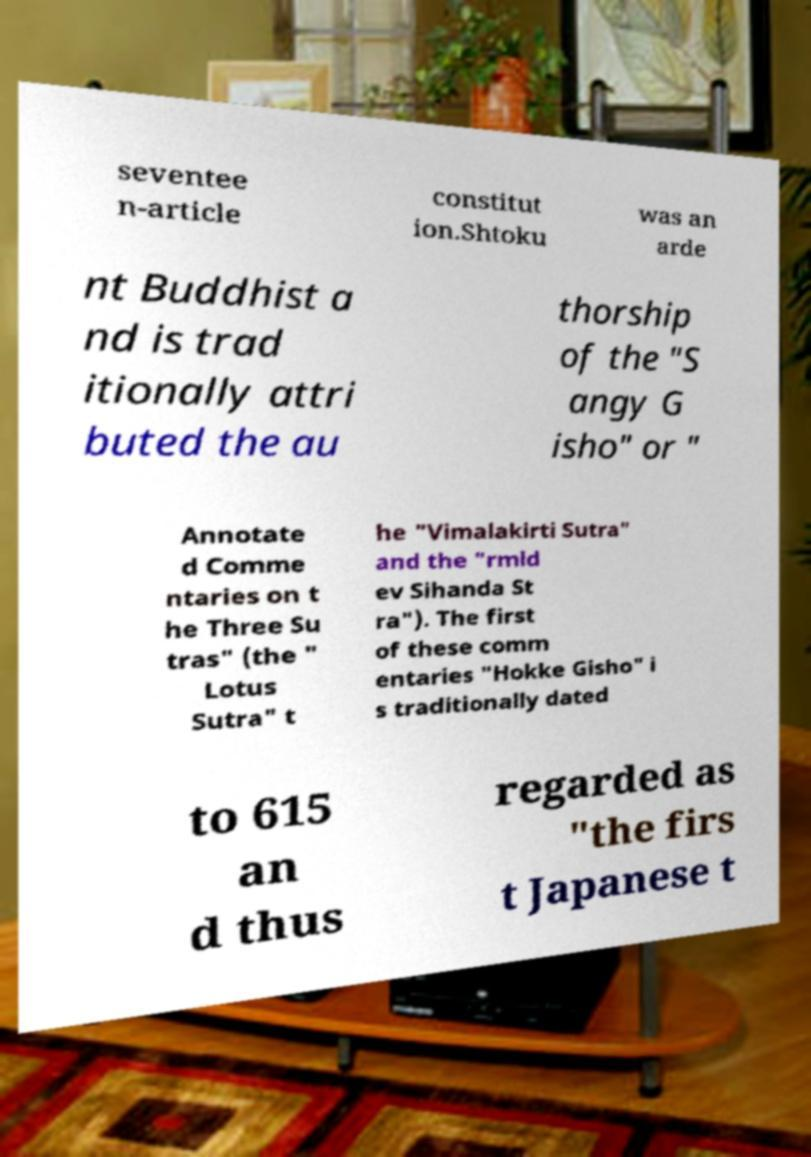Could you assist in decoding the text presented in this image and type it out clearly? seventee n-article constitut ion.Shtoku was an arde nt Buddhist a nd is trad itionally attri buted the au thorship of the "S angy G isho" or " Annotate d Comme ntaries on t he Three Su tras" (the " Lotus Sutra" t he "Vimalakirti Sutra" and the "rmld ev Sihanda St ra"). The first of these comm entaries "Hokke Gisho" i s traditionally dated to 615 an d thus regarded as "the firs t Japanese t 